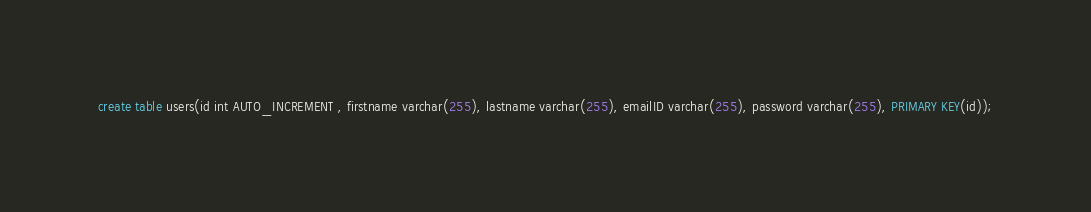<code> <loc_0><loc_0><loc_500><loc_500><_SQL_>create table users(id int AUTO_INCREMENT , firstname varchar(255), lastname varchar(255), emailID varchar(255), password varchar(255), PRIMARY KEY(id));</code> 